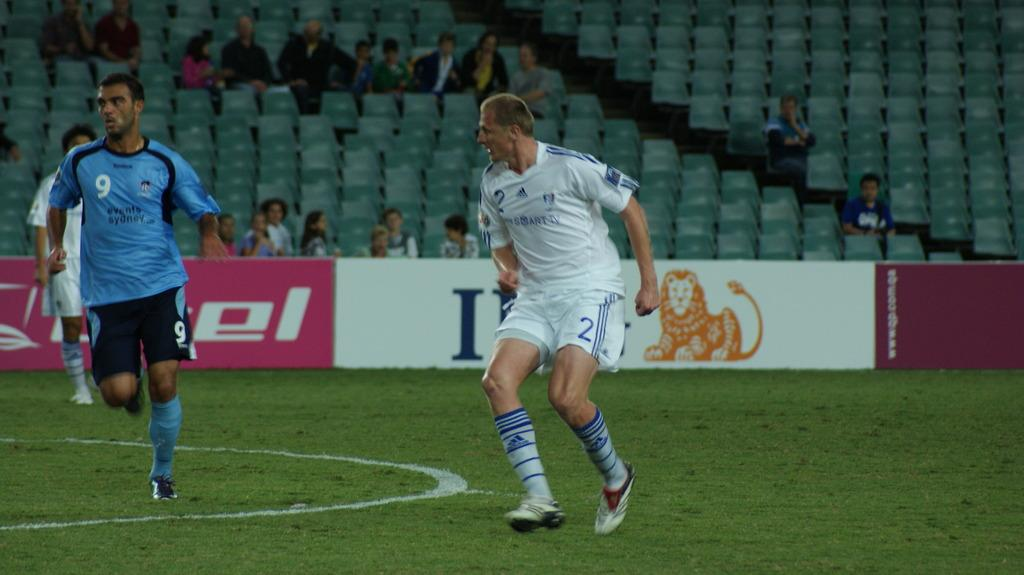Provide a one-sentence caption for the provided image. A man in a blue Reebok shirt playing soccor. 